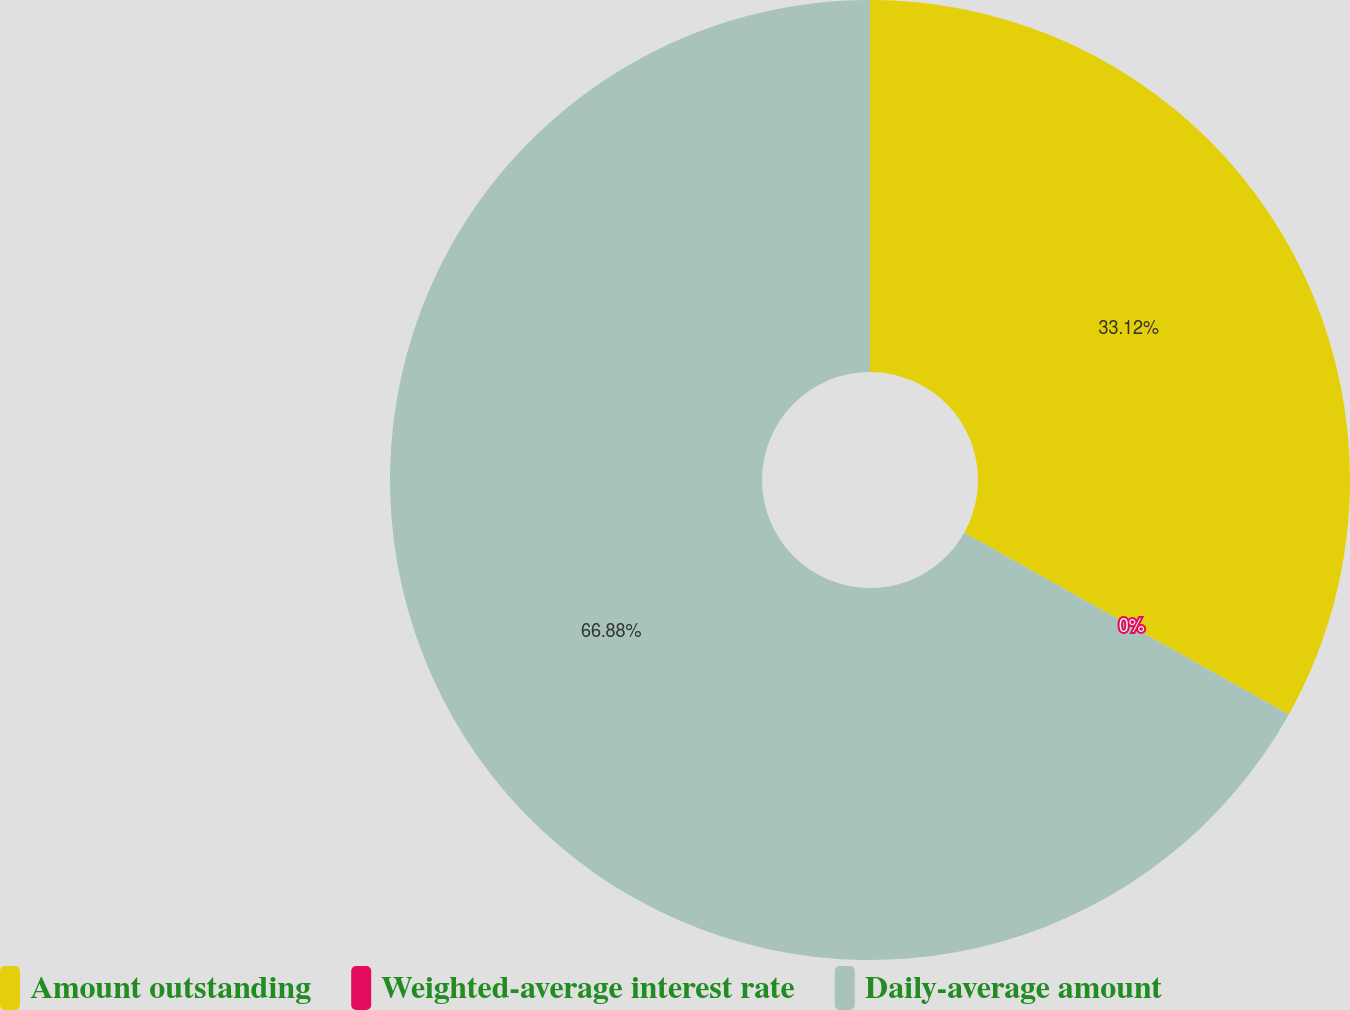Convert chart to OTSL. <chart><loc_0><loc_0><loc_500><loc_500><pie_chart><fcel>Amount outstanding<fcel>Weighted-average interest rate<fcel>Daily-average amount<nl><fcel>33.12%<fcel>0.0%<fcel>66.88%<nl></chart> 